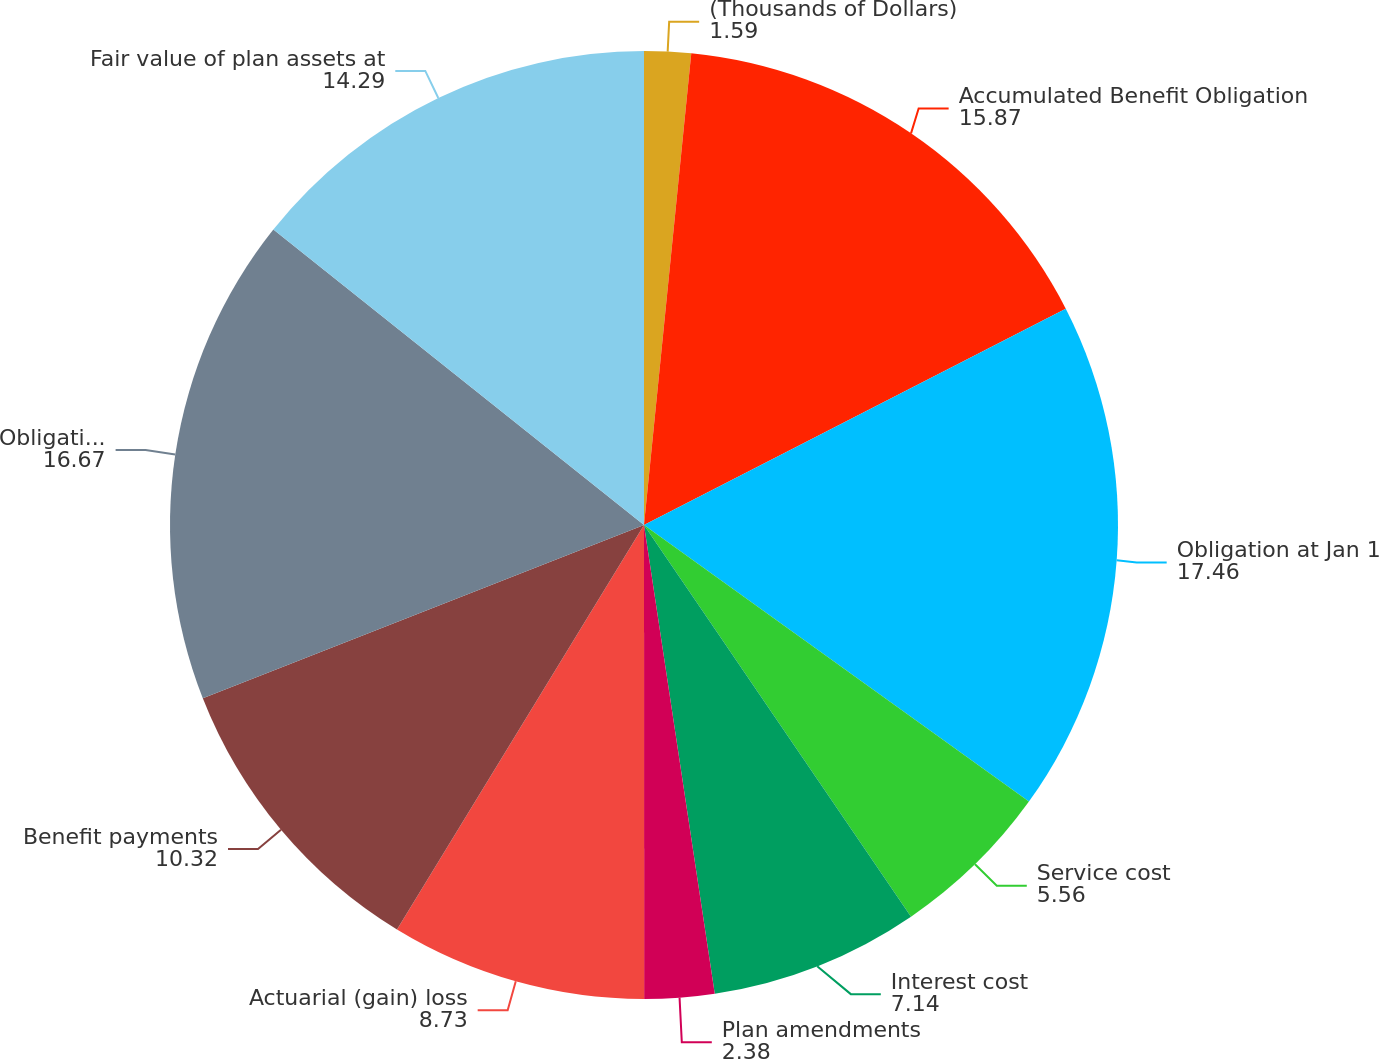Convert chart to OTSL. <chart><loc_0><loc_0><loc_500><loc_500><pie_chart><fcel>(Thousands of Dollars)<fcel>Accumulated Benefit Obligation<fcel>Obligation at Jan 1<fcel>Service cost<fcel>Interest cost<fcel>Plan amendments<fcel>Actuarial (gain) loss<fcel>Benefit payments<fcel>Obligation at Dec 31<fcel>Fair value of plan assets at<nl><fcel>1.59%<fcel>15.87%<fcel>17.46%<fcel>5.56%<fcel>7.14%<fcel>2.38%<fcel>8.73%<fcel>10.32%<fcel>16.67%<fcel>14.29%<nl></chart> 